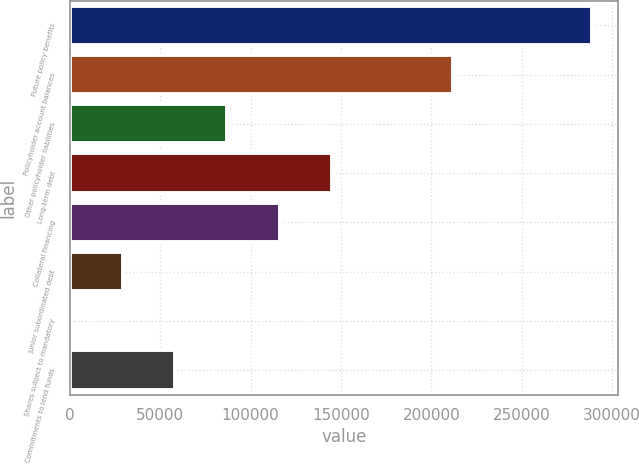Convert chart. <chart><loc_0><loc_0><loc_500><loc_500><bar_chart><fcel>Future policy benefits<fcel>Policyholder account balances<fcel>Other policyholder liabilities<fcel>Long-term debt<fcel>Collateral financing<fcel>Junior subordinated debt<fcel>Shares subject to mandatory<fcel>Commitments to lend funds<nl><fcel>288837<fcel>212049<fcel>87200.6<fcel>144811<fcel>116006<fcel>29590.2<fcel>785<fcel>58395.4<nl></chart> 